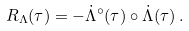<formula> <loc_0><loc_0><loc_500><loc_500>R _ { \Lambda } ( \tau ) = - \dot { \Lambda } ^ { \circ } ( \tau ) \circ \dot { \Lambda } ( \tau ) \, .</formula> 